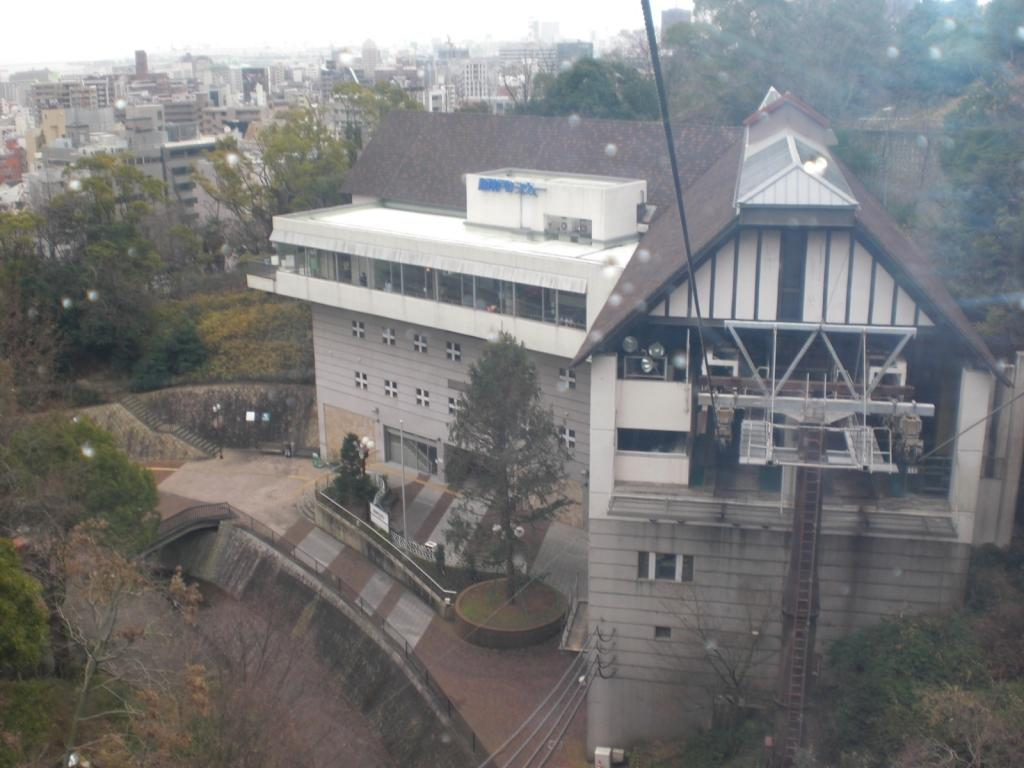What type of structures can be seen in the image? There are buildings in the image. What natural elements are present in the image? There are trees in the image. What man-made objects can be seen in the image? There are wires and a pole at the bottom of the image. What is visible at the top of the image? The sky is visible at the top of the image. Can you describe the haircut of the frog sitting on the pole in the image? There is no frog present in the image, and therefore no haircut to describe. How many fingers can be seen on the person holding the wires in the image? There are no people holding the wires in the image, so it is not possible to determine the number of fingers. 